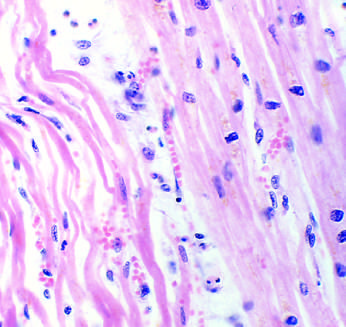re necrotic cells separated by edema fluid?
Answer the question using a single word or phrase. Yes 